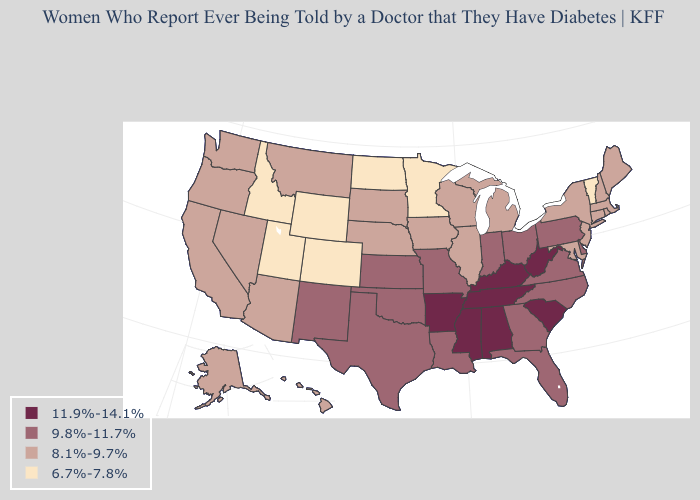How many symbols are there in the legend?
Short answer required. 4. Does the first symbol in the legend represent the smallest category?
Concise answer only. No. Does West Virginia have the highest value in the South?
Write a very short answer. Yes. Which states have the lowest value in the West?
Short answer required. Colorado, Idaho, Utah, Wyoming. Name the states that have a value in the range 8.1%-9.7%?
Keep it brief. Alaska, Arizona, California, Connecticut, Hawaii, Illinois, Iowa, Maine, Maryland, Massachusetts, Michigan, Montana, Nebraska, Nevada, New Hampshire, New Jersey, New York, Oregon, Rhode Island, South Dakota, Washington, Wisconsin. What is the lowest value in the USA?
Write a very short answer. 6.7%-7.8%. Does Colorado have the lowest value in the USA?
Short answer required. Yes. Name the states that have a value in the range 9.8%-11.7%?
Answer briefly. Delaware, Florida, Georgia, Indiana, Kansas, Louisiana, Missouri, New Mexico, North Carolina, Ohio, Oklahoma, Pennsylvania, Texas, Virginia. Among the states that border Nevada , does Idaho have the lowest value?
Keep it brief. Yes. Name the states that have a value in the range 9.8%-11.7%?
Concise answer only. Delaware, Florida, Georgia, Indiana, Kansas, Louisiana, Missouri, New Mexico, North Carolina, Ohio, Oklahoma, Pennsylvania, Texas, Virginia. What is the value of Illinois?
Answer briefly. 8.1%-9.7%. What is the lowest value in the Northeast?
Keep it brief. 6.7%-7.8%. Name the states that have a value in the range 9.8%-11.7%?
Concise answer only. Delaware, Florida, Georgia, Indiana, Kansas, Louisiana, Missouri, New Mexico, North Carolina, Ohio, Oklahoma, Pennsylvania, Texas, Virginia. Name the states that have a value in the range 8.1%-9.7%?
Concise answer only. Alaska, Arizona, California, Connecticut, Hawaii, Illinois, Iowa, Maine, Maryland, Massachusetts, Michigan, Montana, Nebraska, Nevada, New Hampshire, New Jersey, New York, Oregon, Rhode Island, South Dakota, Washington, Wisconsin. Does South Dakota have the lowest value in the MidWest?
Short answer required. No. 